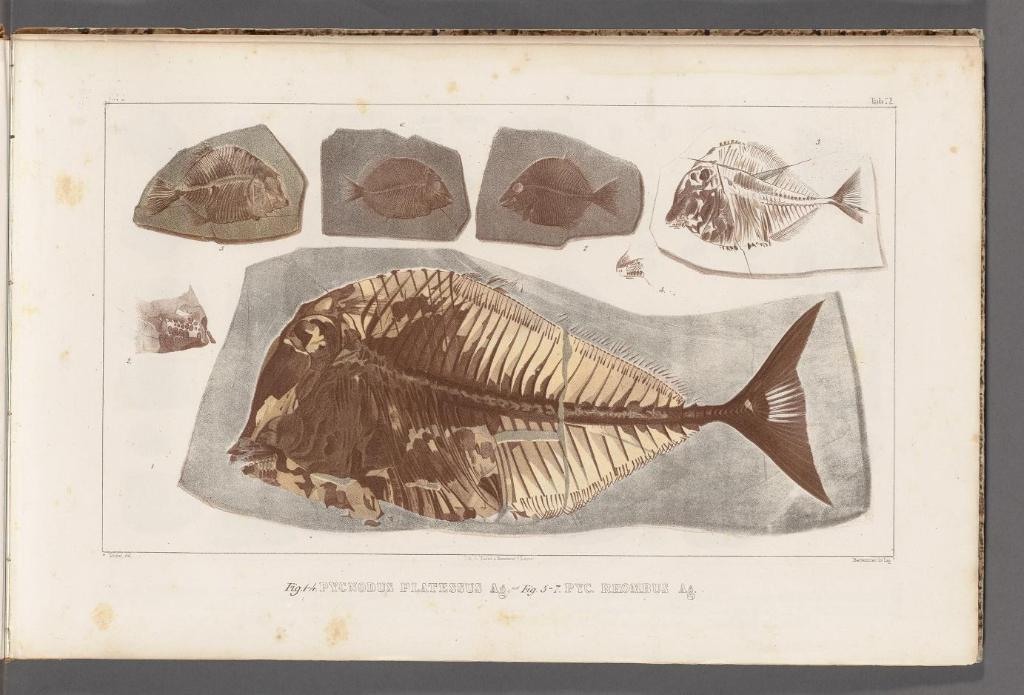In one or two sentences, can you explain what this image depicts? This image consists of a paper with a few images of fish and there is a text on it. In this image the background is gray in color. 